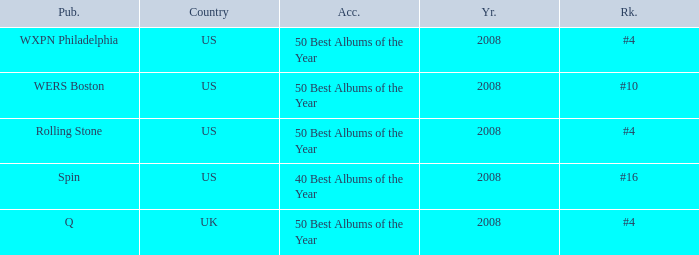Which rank's country is the US when the accolade is 40 best albums of the year? #16. 